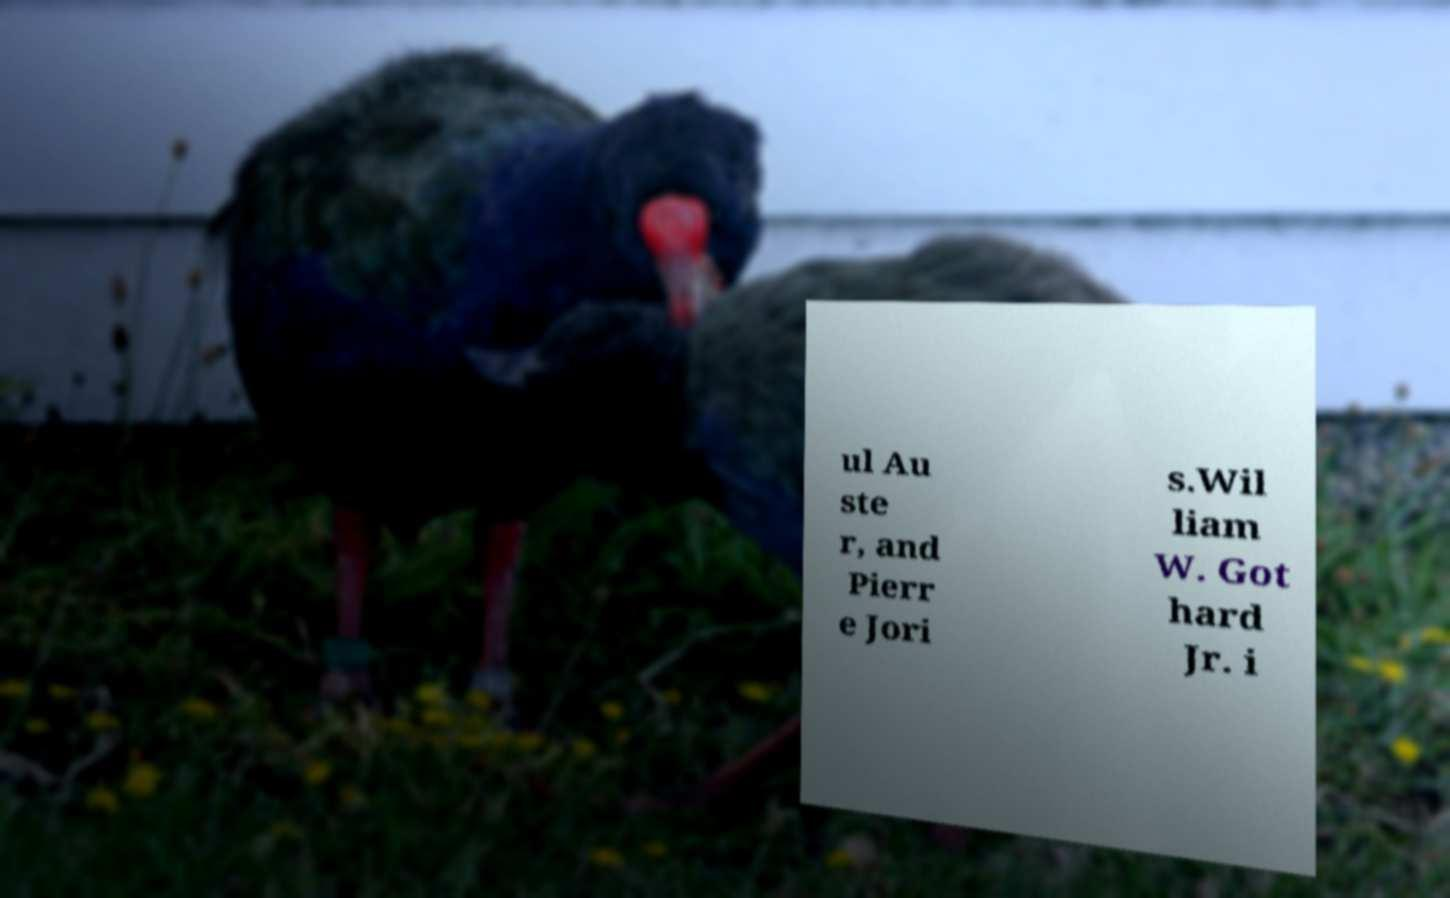Could you assist in decoding the text presented in this image and type it out clearly? ul Au ste r, and Pierr e Jori s.Wil liam W. Got hard Jr. i 